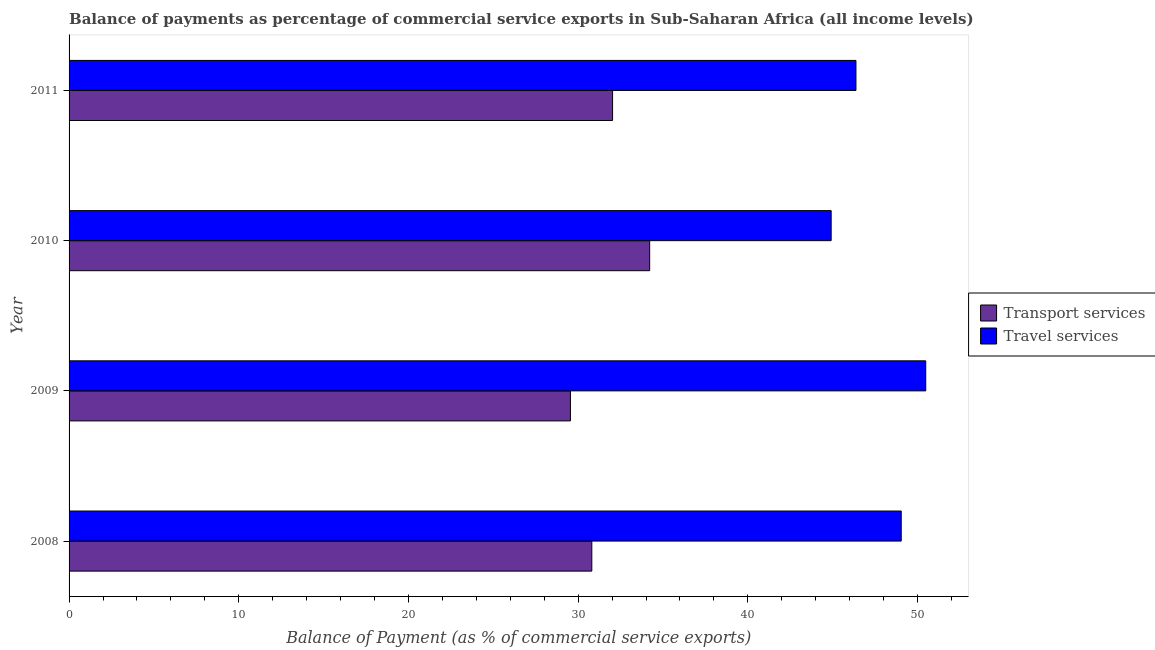How many groups of bars are there?
Give a very brief answer. 4. Are the number of bars on each tick of the Y-axis equal?
Provide a short and direct response. Yes. How many bars are there on the 3rd tick from the bottom?
Give a very brief answer. 2. What is the label of the 1st group of bars from the top?
Provide a short and direct response. 2011. In how many cases, is the number of bars for a given year not equal to the number of legend labels?
Provide a succinct answer. 0. What is the balance of payments of transport services in 2010?
Your response must be concise. 34.21. Across all years, what is the maximum balance of payments of transport services?
Offer a very short reply. 34.21. Across all years, what is the minimum balance of payments of transport services?
Make the answer very short. 29.54. In which year was the balance of payments of transport services maximum?
Give a very brief answer. 2010. What is the total balance of payments of transport services in the graph?
Offer a very short reply. 126.59. What is the difference between the balance of payments of travel services in 2008 and that in 2010?
Offer a terse response. 4.13. What is the difference between the balance of payments of transport services in 2011 and the balance of payments of travel services in 2009?
Your answer should be very brief. -18.45. What is the average balance of payments of transport services per year?
Offer a very short reply. 31.65. In the year 2010, what is the difference between the balance of payments of transport services and balance of payments of travel services?
Keep it short and to the point. -10.69. What is the ratio of the balance of payments of travel services in 2008 to that in 2011?
Offer a terse response. 1.06. Is the difference between the balance of payments of transport services in 2009 and 2010 greater than the difference between the balance of payments of travel services in 2009 and 2010?
Your answer should be compact. No. What is the difference between the highest and the second highest balance of payments of travel services?
Your answer should be very brief. 1.45. What is the difference between the highest and the lowest balance of payments of transport services?
Provide a short and direct response. 4.67. In how many years, is the balance of payments of transport services greater than the average balance of payments of transport services taken over all years?
Provide a short and direct response. 2. What does the 2nd bar from the top in 2011 represents?
Provide a succinct answer. Transport services. What does the 1st bar from the bottom in 2009 represents?
Ensure brevity in your answer.  Transport services. How many bars are there?
Provide a succinct answer. 8. Are all the bars in the graph horizontal?
Offer a very short reply. Yes. How many years are there in the graph?
Your answer should be compact. 4. Does the graph contain grids?
Ensure brevity in your answer.  No. How many legend labels are there?
Make the answer very short. 2. How are the legend labels stacked?
Provide a succinct answer. Vertical. What is the title of the graph?
Provide a short and direct response. Balance of payments as percentage of commercial service exports in Sub-Saharan Africa (all income levels). What is the label or title of the X-axis?
Ensure brevity in your answer.  Balance of Payment (as % of commercial service exports). What is the label or title of the Y-axis?
Ensure brevity in your answer.  Year. What is the Balance of Payment (as % of commercial service exports) of Transport services in 2008?
Your answer should be compact. 30.8. What is the Balance of Payment (as % of commercial service exports) of Travel services in 2008?
Give a very brief answer. 49.04. What is the Balance of Payment (as % of commercial service exports) of Transport services in 2009?
Give a very brief answer. 29.54. What is the Balance of Payment (as % of commercial service exports) in Travel services in 2009?
Provide a succinct answer. 50.48. What is the Balance of Payment (as % of commercial service exports) of Transport services in 2010?
Provide a succinct answer. 34.21. What is the Balance of Payment (as % of commercial service exports) of Travel services in 2010?
Give a very brief answer. 44.91. What is the Balance of Payment (as % of commercial service exports) of Transport services in 2011?
Give a very brief answer. 32.03. What is the Balance of Payment (as % of commercial service exports) of Travel services in 2011?
Ensure brevity in your answer.  46.37. Across all years, what is the maximum Balance of Payment (as % of commercial service exports) of Transport services?
Give a very brief answer. 34.21. Across all years, what is the maximum Balance of Payment (as % of commercial service exports) in Travel services?
Make the answer very short. 50.48. Across all years, what is the minimum Balance of Payment (as % of commercial service exports) in Transport services?
Give a very brief answer. 29.54. Across all years, what is the minimum Balance of Payment (as % of commercial service exports) of Travel services?
Keep it short and to the point. 44.91. What is the total Balance of Payment (as % of commercial service exports) of Transport services in the graph?
Offer a terse response. 126.59. What is the total Balance of Payment (as % of commercial service exports) in Travel services in the graph?
Provide a short and direct response. 190.79. What is the difference between the Balance of Payment (as % of commercial service exports) in Transport services in 2008 and that in 2009?
Your answer should be compact. 1.26. What is the difference between the Balance of Payment (as % of commercial service exports) of Travel services in 2008 and that in 2009?
Provide a succinct answer. -1.44. What is the difference between the Balance of Payment (as % of commercial service exports) of Transport services in 2008 and that in 2010?
Your response must be concise. -3.41. What is the difference between the Balance of Payment (as % of commercial service exports) of Travel services in 2008 and that in 2010?
Your answer should be very brief. 4.13. What is the difference between the Balance of Payment (as % of commercial service exports) of Transport services in 2008 and that in 2011?
Ensure brevity in your answer.  -1.22. What is the difference between the Balance of Payment (as % of commercial service exports) of Travel services in 2008 and that in 2011?
Offer a very short reply. 2.67. What is the difference between the Balance of Payment (as % of commercial service exports) in Transport services in 2009 and that in 2010?
Ensure brevity in your answer.  -4.67. What is the difference between the Balance of Payment (as % of commercial service exports) of Travel services in 2009 and that in 2010?
Keep it short and to the point. 5.57. What is the difference between the Balance of Payment (as % of commercial service exports) in Transport services in 2009 and that in 2011?
Keep it short and to the point. -2.48. What is the difference between the Balance of Payment (as % of commercial service exports) in Travel services in 2009 and that in 2011?
Offer a terse response. 4.11. What is the difference between the Balance of Payment (as % of commercial service exports) of Transport services in 2010 and that in 2011?
Offer a terse response. 2.19. What is the difference between the Balance of Payment (as % of commercial service exports) in Travel services in 2010 and that in 2011?
Make the answer very short. -1.46. What is the difference between the Balance of Payment (as % of commercial service exports) in Transport services in 2008 and the Balance of Payment (as % of commercial service exports) in Travel services in 2009?
Ensure brevity in your answer.  -19.68. What is the difference between the Balance of Payment (as % of commercial service exports) of Transport services in 2008 and the Balance of Payment (as % of commercial service exports) of Travel services in 2010?
Make the answer very short. -14.1. What is the difference between the Balance of Payment (as % of commercial service exports) in Transport services in 2008 and the Balance of Payment (as % of commercial service exports) in Travel services in 2011?
Provide a succinct answer. -15.57. What is the difference between the Balance of Payment (as % of commercial service exports) of Transport services in 2009 and the Balance of Payment (as % of commercial service exports) of Travel services in 2010?
Your answer should be very brief. -15.36. What is the difference between the Balance of Payment (as % of commercial service exports) in Transport services in 2009 and the Balance of Payment (as % of commercial service exports) in Travel services in 2011?
Your answer should be very brief. -16.83. What is the difference between the Balance of Payment (as % of commercial service exports) of Transport services in 2010 and the Balance of Payment (as % of commercial service exports) of Travel services in 2011?
Ensure brevity in your answer.  -12.16. What is the average Balance of Payment (as % of commercial service exports) of Transport services per year?
Offer a terse response. 31.65. What is the average Balance of Payment (as % of commercial service exports) of Travel services per year?
Keep it short and to the point. 47.7. In the year 2008, what is the difference between the Balance of Payment (as % of commercial service exports) in Transport services and Balance of Payment (as % of commercial service exports) in Travel services?
Your response must be concise. -18.23. In the year 2009, what is the difference between the Balance of Payment (as % of commercial service exports) in Transport services and Balance of Payment (as % of commercial service exports) in Travel services?
Your answer should be very brief. -20.94. In the year 2010, what is the difference between the Balance of Payment (as % of commercial service exports) in Transport services and Balance of Payment (as % of commercial service exports) in Travel services?
Offer a terse response. -10.69. In the year 2011, what is the difference between the Balance of Payment (as % of commercial service exports) in Transport services and Balance of Payment (as % of commercial service exports) in Travel services?
Give a very brief answer. -14.34. What is the ratio of the Balance of Payment (as % of commercial service exports) in Transport services in 2008 to that in 2009?
Keep it short and to the point. 1.04. What is the ratio of the Balance of Payment (as % of commercial service exports) of Travel services in 2008 to that in 2009?
Offer a very short reply. 0.97. What is the ratio of the Balance of Payment (as % of commercial service exports) in Transport services in 2008 to that in 2010?
Your response must be concise. 0.9. What is the ratio of the Balance of Payment (as % of commercial service exports) of Travel services in 2008 to that in 2010?
Offer a terse response. 1.09. What is the ratio of the Balance of Payment (as % of commercial service exports) of Transport services in 2008 to that in 2011?
Ensure brevity in your answer.  0.96. What is the ratio of the Balance of Payment (as % of commercial service exports) of Travel services in 2008 to that in 2011?
Keep it short and to the point. 1.06. What is the ratio of the Balance of Payment (as % of commercial service exports) of Transport services in 2009 to that in 2010?
Your answer should be compact. 0.86. What is the ratio of the Balance of Payment (as % of commercial service exports) of Travel services in 2009 to that in 2010?
Offer a very short reply. 1.12. What is the ratio of the Balance of Payment (as % of commercial service exports) in Transport services in 2009 to that in 2011?
Your answer should be compact. 0.92. What is the ratio of the Balance of Payment (as % of commercial service exports) in Travel services in 2009 to that in 2011?
Your answer should be very brief. 1.09. What is the ratio of the Balance of Payment (as % of commercial service exports) in Transport services in 2010 to that in 2011?
Your response must be concise. 1.07. What is the ratio of the Balance of Payment (as % of commercial service exports) in Travel services in 2010 to that in 2011?
Ensure brevity in your answer.  0.97. What is the difference between the highest and the second highest Balance of Payment (as % of commercial service exports) of Transport services?
Keep it short and to the point. 2.19. What is the difference between the highest and the second highest Balance of Payment (as % of commercial service exports) of Travel services?
Offer a terse response. 1.44. What is the difference between the highest and the lowest Balance of Payment (as % of commercial service exports) of Transport services?
Make the answer very short. 4.67. What is the difference between the highest and the lowest Balance of Payment (as % of commercial service exports) of Travel services?
Provide a succinct answer. 5.57. 